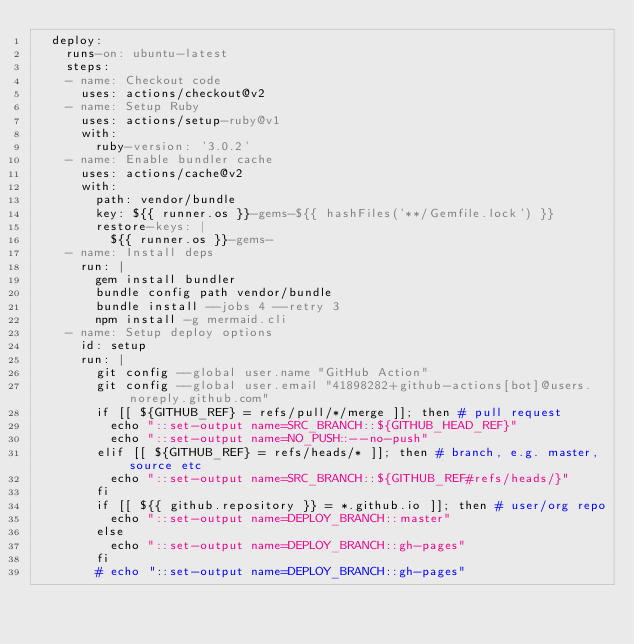<code> <loc_0><loc_0><loc_500><loc_500><_YAML_>  deploy:
    runs-on: ubuntu-latest
    steps:
    - name: Checkout code
      uses: actions/checkout@v2
    - name: Setup Ruby
      uses: actions/setup-ruby@v1
      with:
        ruby-version: '3.0.2'
    - name: Enable bundler cache
      uses: actions/cache@v2
      with:
        path: vendor/bundle
        key: ${{ runner.os }}-gems-${{ hashFiles('**/Gemfile.lock') }}
        restore-keys: |
          ${{ runner.os }}-gems-
    - name: Install deps
      run: |
        gem install bundler
        bundle config path vendor/bundle
        bundle install --jobs 4 --retry 3
        npm install -g mermaid.cli
    - name: Setup deploy options
      id: setup
      run: |
        git config --global user.name "GitHub Action"
        git config --global user.email "41898282+github-actions[bot]@users.noreply.github.com"
        if [[ ${GITHUB_REF} = refs/pull/*/merge ]]; then # pull request
          echo "::set-output name=SRC_BRANCH::${GITHUB_HEAD_REF}"
          echo "::set-output name=NO_PUSH::--no-push"
        elif [[ ${GITHUB_REF} = refs/heads/* ]]; then # branch, e.g. master, source etc
          echo "::set-output name=SRC_BRANCH::${GITHUB_REF#refs/heads/}"
        fi
        if [[ ${{ github.repository }} = *.github.io ]]; then # user/org repo
          echo "::set-output name=DEPLOY_BRANCH::master"
        else
          echo "::set-output name=DEPLOY_BRANCH::gh-pages"
        fi
        # echo "::set-output name=DEPLOY_BRANCH::gh-pages"</code> 